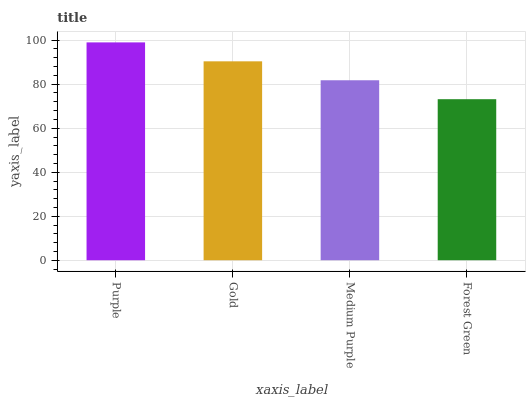Is Forest Green the minimum?
Answer yes or no. Yes. Is Purple the maximum?
Answer yes or no. Yes. Is Gold the minimum?
Answer yes or no. No. Is Gold the maximum?
Answer yes or no. No. Is Purple greater than Gold?
Answer yes or no. Yes. Is Gold less than Purple?
Answer yes or no. Yes. Is Gold greater than Purple?
Answer yes or no. No. Is Purple less than Gold?
Answer yes or no. No. Is Gold the high median?
Answer yes or no. Yes. Is Medium Purple the low median?
Answer yes or no. Yes. Is Medium Purple the high median?
Answer yes or no. No. Is Gold the low median?
Answer yes or no. No. 